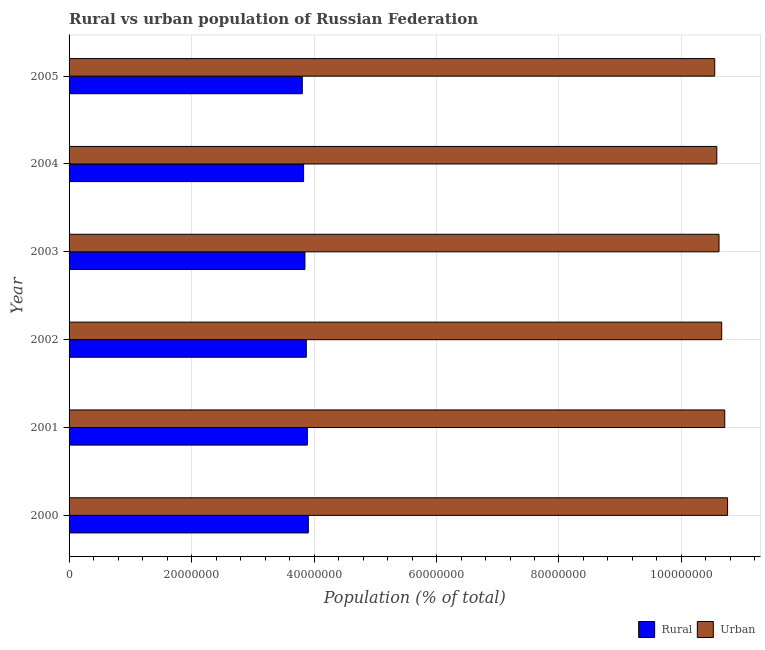How many different coloured bars are there?
Keep it short and to the point. 2. How many bars are there on the 2nd tick from the top?
Your response must be concise. 2. How many bars are there on the 6th tick from the bottom?
Keep it short and to the point. 2. What is the label of the 6th group of bars from the top?
Make the answer very short. 2000. In how many cases, is the number of bars for a given year not equal to the number of legend labels?
Provide a short and direct response. 0. What is the rural population density in 2001?
Ensure brevity in your answer.  3.89e+07. Across all years, what is the maximum urban population density?
Ensure brevity in your answer.  1.08e+08. Across all years, what is the minimum rural population density?
Provide a succinct answer. 3.81e+07. What is the total rural population density in the graph?
Your answer should be compact. 2.32e+08. What is the difference between the rural population density in 2002 and that in 2005?
Give a very brief answer. 6.52e+05. What is the difference between the urban population density in 2004 and the rural population density in 2000?
Make the answer very short. 6.67e+07. What is the average urban population density per year?
Make the answer very short. 1.06e+08. In the year 2001, what is the difference between the urban population density and rural population density?
Your answer should be very brief. 6.82e+07. What is the ratio of the urban population density in 2002 to that in 2003?
Ensure brevity in your answer.  1. Is the difference between the rural population density in 2000 and 2005 greater than the difference between the urban population density in 2000 and 2005?
Give a very brief answer. No. What is the difference between the highest and the second highest urban population density?
Your response must be concise. 4.61e+05. What is the difference between the highest and the lowest rural population density?
Provide a succinct answer. 9.82e+05. Is the sum of the rural population density in 2001 and 2004 greater than the maximum urban population density across all years?
Provide a short and direct response. No. What does the 1st bar from the top in 2005 represents?
Keep it short and to the point. Urban. What does the 2nd bar from the bottom in 2000 represents?
Your response must be concise. Urban. Are all the bars in the graph horizontal?
Offer a very short reply. Yes. What is the difference between two consecutive major ticks on the X-axis?
Your answer should be compact. 2.00e+07. Does the graph contain grids?
Keep it short and to the point. Yes. How many legend labels are there?
Offer a terse response. 2. How are the legend labels stacked?
Ensure brevity in your answer.  Horizontal. What is the title of the graph?
Your response must be concise. Rural vs urban population of Russian Federation. Does "Short-term debt" appear as one of the legend labels in the graph?
Offer a very short reply. No. What is the label or title of the X-axis?
Provide a succinct answer. Population (% of total). What is the Population (% of total) of Rural in 2000?
Offer a terse response. 3.91e+07. What is the Population (% of total) in Urban in 2000?
Make the answer very short. 1.08e+08. What is the Population (% of total) in Rural in 2001?
Provide a succinct answer. 3.89e+07. What is the Population (% of total) in Urban in 2001?
Offer a terse response. 1.07e+08. What is the Population (% of total) in Rural in 2002?
Keep it short and to the point. 3.87e+07. What is the Population (% of total) of Urban in 2002?
Make the answer very short. 1.07e+08. What is the Population (% of total) of Rural in 2003?
Offer a very short reply. 3.85e+07. What is the Population (% of total) of Urban in 2003?
Make the answer very short. 1.06e+08. What is the Population (% of total) of Rural in 2004?
Offer a very short reply. 3.83e+07. What is the Population (% of total) in Urban in 2004?
Offer a very short reply. 1.06e+08. What is the Population (% of total) in Rural in 2005?
Provide a succinct answer. 3.81e+07. What is the Population (% of total) in Urban in 2005?
Your answer should be very brief. 1.05e+08. Across all years, what is the maximum Population (% of total) in Rural?
Offer a very short reply. 3.91e+07. Across all years, what is the maximum Population (% of total) of Urban?
Keep it short and to the point. 1.08e+08. Across all years, what is the minimum Population (% of total) in Rural?
Ensure brevity in your answer.  3.81e+07. Across all years, what is the minimum Population (% of total) in Urban?
Provide a short and direct response. 1.05e+08. What is the total Population (% of total) in Rural in the graph?
Keep it short and to the point. 2.32e+08. What is the total Population (% of total) in Urban in the graph?
Your response must be concise. 6.39e+08. What is the difference between the Population (% of total) of Rural in 2000 and that in 2001?
Provide a succinct answer. 1.60e+05. What is the difference between the Population (% of total) of Urban in 2000 and that in 2001?
Give a very brief answer. 4.61e+05. What is the difference between the Population (% of total) of Rural in 2000 and that in 2002?
Ensure brevity in your answer.  3.31e+05. What is the difference between the Population (% of total) in Urban in 2000 and that in 2002?
Keep it short and to the point. 9.60e+05. What is the difference between the Population (% of total) of Rural in 2000 and that in 2003?
Provide a short and direct response. 5.52e+05. What is the difference between the Population (% of total) of Urban in 2000 and that in 2003?
Provide a succinct answer. 1.40e+06. What is the difference between the Population (% of total) of Rural in 2000 and that in 2004?
Ensure brevity in your answer.  7.72e+05. What is the difference between the Population (% of total) of Urban in 2000 and that in 2004?
Your answer should be compact. 1.76e+06. What is the difference between the Population (% of total) in Rural in 2000 and that in 2005?
Make the answer very short. 9.82e+05. What is the difference between the Population (% of total) of Urban in 2000 and that in 2005?
Offer a terse response. 2.10e+06. What is the difference between the Population (% of total) of Rural in 2001 and that in 2002?
Your response must be concise. 1.71e+05. What is the difference between the Population (% of total) of Urban in 2001 and that in 2002?
Give a very brief answer. 4.99e+05. What is the difference between the Population (% of total) in Rural in 2001 and that in 2003?
Keep it short and to the point. 3.93e+05. What is the difference between the Population (% of total) of Urban in 2001 and that in 2003?
Your answer should be very brief. 9.35e+05. What is the difference between the Population (% of total) of Rural in 2001 and that in 2004?
Keep it short and to the point. 6.13e+05. What is the difference between the Population (% of total) in Urban in 2001 and that in 2004?
Offer a very short reply. 1.30e+06. What is the difference between the Population (% of total) of Rural in 2001 and that in 2005?
Give a very brief answer. 8.23e+05. What is the difference between the Population (% of total) in Urban in 2001 and that in 2005?
Ensure brevity in your answer.  1.63e+06. What is the difference between the Population (% of total) of Rural in 2002 and that in 2003?
Your response must be concise. 2.22e+05. What is the difference between the Population (% of total) of Urban in 2002 and that in 2003?
Offer a very short reply. 4.36e+05. What is the difference between the Population (% of total) in Rural in 2002 and that in 2004?
Ensure brevity in your answer.  4.41e+05. What is the difference between the Population (% of total) of Urban in 2002 and that in 2004?
Offer a terse response. 7.98e+05. What is the difference between the Population (% of total) in Rural in 2002 and that in 2005?
Keep it short and to the point. 6.52e+05. What is the difference between the Population (% of total) of Urban in 2002 and that in 2005?
Keep it short and to the point. 1.14e+06. What is the difference between the Population (% of total) of Rural in 2003 and that in 2004?
Offer a very short reply. 2.20e+05. What is the difference between the Population (% of total) of Urban in 2003 and that in 2004?
Provide a short and direct response. 3.62e+05. What is the difference between the Population (% of total) of Rural in 2003 and that in 2005?
Provide a short and direct response. 4.30e+05. What is the difference between the Population (% of total) of Urban in 2003 and that in 2005?
Your answer should be compact. 7.00e+05. What is the difference between the Population (% of total) in Rural in 2004 and that in 2005?
Your response must be concise. 2.10e+05. What is the difference between the Population (% of total) in Urban in 2004 and that in 2005?
Keep it short and to the point. 3.38e+05. What is the difference between the Population (% of total) in Rural in 2000 and the Population (% of total) in Urban in 2001?
Offer a very short reply. -6.80e+07. What is the difference between the Population (% of total) in Rural in 2000 and the Population (% of total) in Urban in 2002?
Keep it short and to the point. -6.75e+07. What is the difference between the Population (% of total) of Rural in 2000 and the Population (% of total) of Urban in 2003?
Your answer should be very brief. -6.71e+07. What is the difference between the Population (% of total) in Rural in 2000 and the Population (% of total) in Urban in 2004?
Provide a short and direct response. -6.67e+07. What is the difference between the Population (% of total) of Rural in 2000 and the Population (% of total) of Urban in 2005?
Make the answer very short. -6.64e+07. What is the difference between the Population (% of total) in Rural in 2001 and the Population (% of total) in Urban in 2002?
Your response must be concise. -6.77e+07. What is the difference between the Population (% of total) of Rural in 2001 and the Population (% of total) of Urban in 2003?
Your answer should be compact. -6.72e+07. What is the difference between the Population (% of total) of Rural in 2001 and the Population (% of total) of Urban in 2004?
Provide a short and direct response. -6.69e+07. What is the difference between the Population (% of total) in Rural in 2001 and the Population (% of total) in Urban in 2005?
Ensure brevity in your answer.  -6.65e+07. What is the difference between the Population (% of total) in Rural in 2002 and the Population (% of total) in Urban in 2003?
Provide a succinct answer. -6.74e+07. What is the difference between the Population (% of total) of Rural in 2002 and the Population (% of total) of Urban in 2004?
Your answer should be compact. -6.70e+07. What is the difference between the Population (% of total) of Rural in 2002 and the Population (% of total) of Urban in 2005?
Your response must be concise. -6.67e+07. What is the difference between the Population (% of total) in Rural in 2003 and the Population (% of total) in Urban in 2004?
Keep it short and to the point. -6.73e+07. What is the difference between the Population (% of total) in Rural in 2003 and the Population (% of total) in Urban in 2005?
Your answer should be compact. -6.69e+07. What is the difference between the Population (% of total) in Rural in 2004 and the Population (% of total) in Urban in 2005?
Keep it short and to the point. -6.71e+07. What is the average Population (% of total) in Rural per year?
Your answer should be compact. 3.86e+07. What is the average Population (% of total) of Urban per year?
Make the answer very short. 1.06e+08. In the year 2000, what is the difference between the Population (% of total) in Rural and Population (% of total) in Urban?
Your answer should be compact. -6.85e+07. In the year 2001, what is the difference between the Population (% of total) in Rural and Population (% of total) in Urban?
Your answer should be compact. -6.82e+07. In the year 2002, what is the difference between the Population (% of total) of Rural and Population (% of total) of Urban?
Your response must be concise. -6.78e+07. In the year 2003, what is the difference between the Population (% of total) of Rural and Population (% of total) of Urban?
Your answer should be compact. -6.76e+07. In the year 2004, what is the difference between the Population (% of total) in Rural and Population (% of total) in Urban?
Provide a short and direct response. -6.75e+07. In the year 2005, what is the difference between the Population (% of total) in Rural and Population (% of total) in Urban?
Provide a succinct answer. -6.73e+07. What is the ratio of the Population (% of total) of Rural in 2000 to that in 2001?
Provide a succinct answer. 1. What is the ratio of the Population (% of total) of Rural in 2000 to that in 2002?
Give a very brief answer. 1.01. What is the ratio of the Population (% of total) of Urban in 2000 to that in 2002?
Make the answer very short. 1.01. What is the ratio of the Population (% of total) of Rural in 2000 to that in 2003?
Give a very brief answer. 1.01. What is the ratio of the Population (% of total) in Urban in 2000 to that in 2003?
Offer a very short reply. 1.01. What is the ratio of the Population (% of total) in Rural in 2000 to that in 2004?
Provide a short and direct response. 1.02. What is the ratio of the Population (% of total) of Urban in 2000 to that in 2004?
Give a very brief answer. 1.02. What is the ratio of the Population (% of total) of Rural in 2000 to that in 2005?
Offer a very short reply. 1.03. What is the ratio of the Population (% of total) of Urban in 2000 to that in 2005?
Your response must be concise. 1.02. What is the ratio of the Population (% of total) in Rural in 2001 to that in 2003?
Provide a succinct answer. 1.01. What is the ratio of the Population (% of total) in Urban in 2001 to that in 2003?
Make the answer very short. 1.01. What is the ratio of the Population (% of total) in Rural in 2001 to that in 2004?
Ensure brevity in your answer.  1.02. What is the ratio of the Population (% of total) in Urban in 2001 to that in 2004?
Provide a short and direct response. 1.01. What is the ratio of the Population (% of total) of Rural in 2001 to that in 2005?
Your answer should be very brief. 1.02. What is the ratio of the Population (% of total) of Urban in 2001 to that in 2005?
Make the answer very short. 1.02. What is the ratio of the Population (% of total) of Urban in 2002 to that in 2003?
Ensure brevity in your answer.  1. What is the ratio of the Population (% of total) of Rural in 2002 to that in 2004?
Offer a very short reply. 1.01. What is the ratio of the Population (% of total) of Urban in 2002 to that in 2004?
Give a very brief answer. 1.01. What is the ratio of the Population (% of total) in Rural in 2002 to that in 2005?
Provide a succinct answer. 1.02. What is the ratio of the Population (% of total) in Urban in 2002 to that in 2005?
Your response must be concise. 1.01. What is the ratio of the Population (% of total) of Urban in 2003 to that in 2004?
Your response must be concise. 1. What is the ratio of the Population (% of total) in Rural in 2003 to that in 2005?
Provide a short and direct response. 1.01. What is the ratio of the Population (% of total) in Urban in 2003 to that in 2005?
Provide a succinct answer. 1.01. What is the ratio of the Population (% of total) of Urban in 2004 to that in 2005?
Your response must be concise. 1. What is the difference between the highest and the second highest Population (% of total) in Rural?
Provide a short and direct response. 1.60e+05. What is the difference between the highest and the second highest Population (% of total) in Urban?
Your response must be concise. 4.61e+05. What is the difference between the highest and the lowest Population (% of total) of Rural?
Keep it short and to the point. 9.82e+05. What is the difference between the highest and the lowest Population (% of total) in Urban?
Offer a terse response. 2.10e+06. 